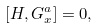<formula> <loc_0><loc_0><loc_500><loc_500>[ H , G ^ { a } _ { x } ] = 0 ,</formula> 